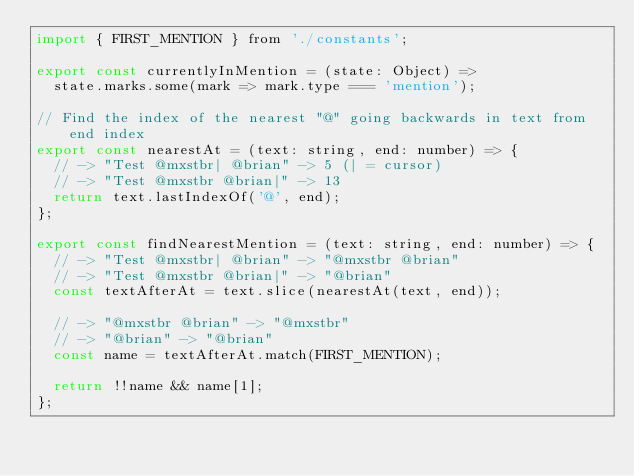<code> <loc_0><loc_0><loc_500><loc_500><_JavaScript_>import { FIRST_MENTION } from './constants';

export const currentlyInMention = (state: Object) =>
  state.marks.some(mark => mark.type === 'mention');

// Find the index of the nearest "@" going backwards in text from end index
export const nearestAt = (text: string, end: number) => {
  // -> "Test @mxstbr| @brian" -> 5 (| = cursor)
  // -> "Test @mxstbr @brian|" -> 13
  return text.lastIndexOf('@', end);
};

export const findNearestMention = (text: string, end: number) => {
  // -> "Test @mxstbr| @brian" -> "@mxstbr @brian"
  // -> "Test @mxstbr @brian|" -> "@brian"
  const textAfterAt = text.slice(nearestAt(text, end));

  // -> "@mxstbr @brian" -> "@mxstbr"
  // -> "@brian" -> "@brian"
  const name = textAfterAt.match(FIRST_MENTION);

  return !!name && name[1];
};
</code> 